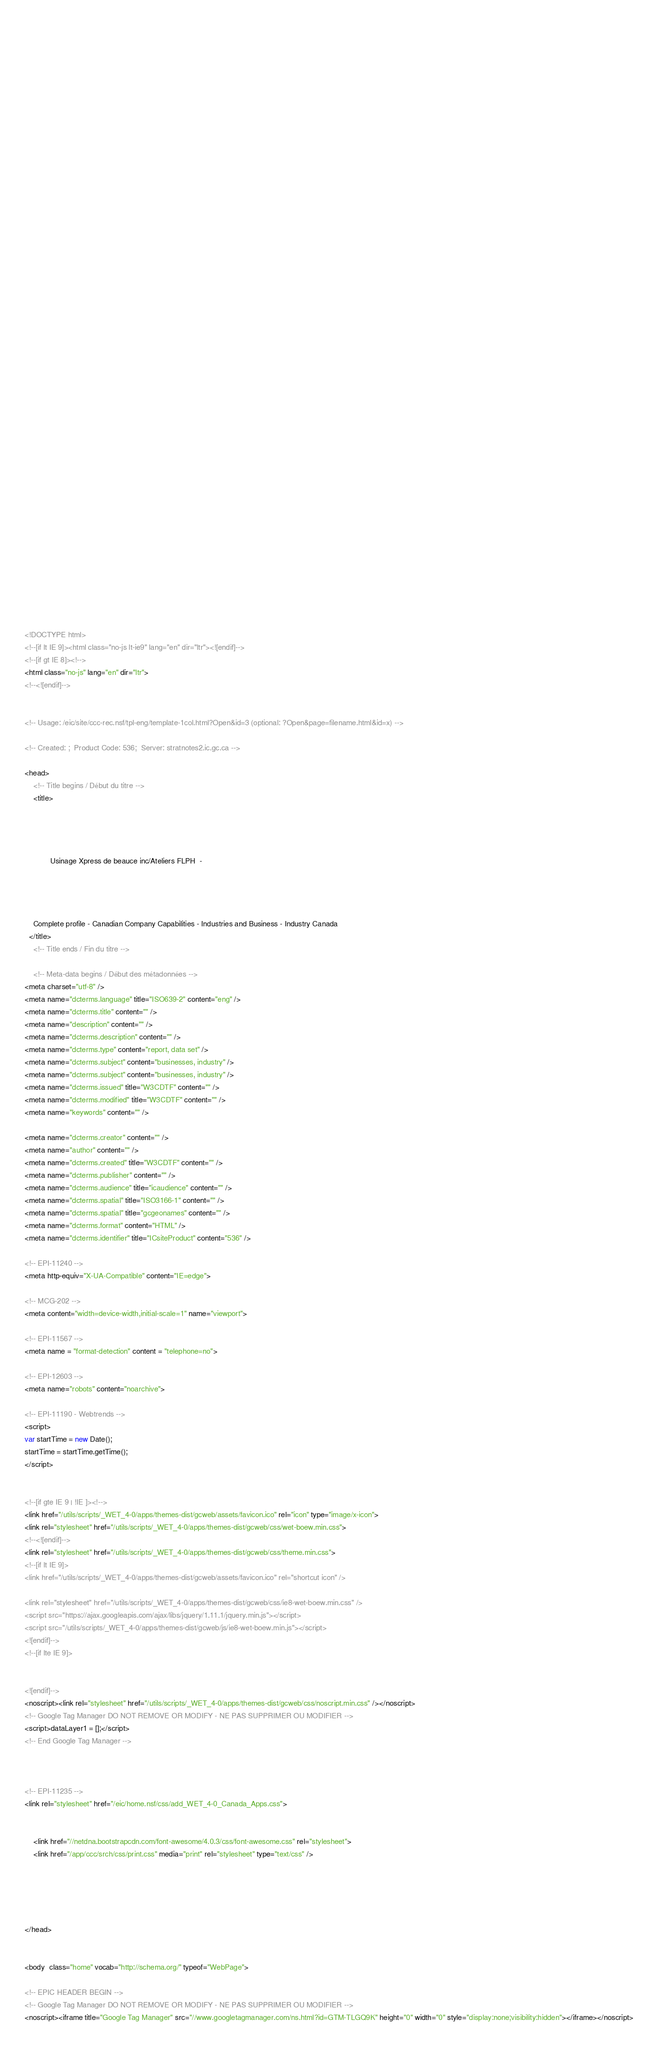<code> <loc_0><loc_0><loc_500><loc_500><_HTML_>


















	






  
  
  
  































	
	
	



<!DOCTYPE html>
<!--[if lt IE 9]><html class="no-js lt-ie9" lang="en" dir="ltr"><![endif]-->
<!--[if gt IE 8]><!-->
<html class="no-js" lang="en" dir="ltr">
<!--<![endif]-->


<!-- Usage: /eic/site/ccc-rec.nsf/tpl-eng/template-1col.html?Open&id=3 (optional: ?Open&page=filename.html&id=x) -->

<!-- Created: ;  Product Code: 536;  Server: stratnotes2.ic.gc.ca -->

<head>
	<!-- Title begins / Début du titre -->
	<title>
    
            
        
          
            Usinage Xpress de beauce inc/Ateliers FLPH  -
          
        
      
    
    Complete profile - Canadian Company Capabilities - Industries and Business - Industry Canada
  </title>
	<!-- Title ends / Fin du titre -->
 
	<!-- Meta-data begins / Début des métadonnées -->
<meta charset="utf-8" />
<meta name="dcterms.language" title="ISO639-2" content="eng" />
<meta name="dcterms.title" content="" />
<meta name="description" content="" />
<meta name="dcterms.description" content="" />
<meta name="dcterms.type" content="report, data set" />
<meta name="dcterms.subject" content="businesses, industry" />
<meta name="dcterms.subject" content="businesses, industry" />
<meta name="dcterms.issued" title="W3CDTF" content="" />
<meta name="dcterms.modified" title="W3CDTF" content="" />
<meta name="keywords" content="" />

<meta name="dcterms.creator" content="" />
<meta name="author" content="" />
<meta name="dcterms.created" title="W3CDTF" content="" />
<meta name="dcterms.publisher" content="" />
<meta name="dcterms.audience" title="icaudience" content="" />
<meta name="dcterms.spatial" title="ISO3166-1" content="" />
<meta name="dcterms.spatial" title="gcgeonames" content="" />
<meta name="dcterms.format" content="HTML" />
<meta name="dcterms.identifier" title="ICsiteProduct" content="536" />

<!-- EPI-11240 -->
<meta http-equiv="X-UA-Compatible" content="IE=edge">

<!-- MCG-202 -->
<meta content="width=device-width,initial-scale=1" name="viewport">

<!-- EPI-11567 -->
<meta name = "format-detection" content = "telephone=no">

<!-- EPI-12603 -->
<meta name="robots" content="noarchive">

<!-- EPI-11190 - Webtrends -->
<script>
var startTime = new Date();
startTime = startTime.getTime();
</script>


<!--[if gte IE 9 | !IE ]><!-->
<link href="/utils/scripts/_WET_4-0/apps/themes-dist/gcweb/assets/favicon.ico" rel="icon" type="image/x-icon">
<link rel="stylesheet" href="/utils/scripts/_WET_4-0/apps/themes-dist/gcweb/css/wet-boew.min.css">
<!--<![endif]-->
<link rel="stylesheet" href="/utils/scripts/_WET_4-0/apps/themes-dist/gcweb/css/theme.min.css">
<!--[if lt IE 9]>
<link href="/utils/scripts/_WET_4-0/apps/themes-dist/gcweb/assets/favicon.ico" rel="shortcut icon" />

<link rel="stylesheet" href="/utils/scripts/_WET_4-0/apps/themes-dist/gcweb/css/ie8-wet-boew.min.css" />
<script src="https://ajax.googleapis.com/ajax/libs/jquery/1.11.1/jquery.min.js"></script>
<script src="/utils/scripts/_WET_4-0/apps/themes-dist/gcweb/js/ie8-wet-boew.min.js"></script>
<![endif]-->
<!--[if lte IE 9]>


<![endif]-->
<noscript><link rel="stylesheet" href="/utils/scripts/_WET_4-0/apps/themes-dist/gcweb/css/noscript.min.css" /></noscript>
<!-- Google Tag Manager DO NOT REMOVE OR MODIFY - NE PAS SUPPRIMER OU MODIFIER -->
<script>dataLayer1 = [];</script>
<!-- End Google Tag Manager -->



<!-- EPI-11235 -->
<link rel="stylesheet" href="/eic/home.nsf/css/add_WET_4-0_Canada_Apps.css">


  	<link href="//netdna.bootstrapcdn.com/font-awesome/4.0.3/css/font-awesome.css" rel="stylesheet">
  	<link href="/app/ccc/srch/css/print.css" media="print" rel="stylesheet" type="text/css" />
   




</head>
 

<body  class="home" vocab="http://schema.org/" typeof="WebPage">
 
<!-- EPIC HEADER BEGIN -->
<!-- Google Tag Manager DO NOT REMOVE OR MODIFY - NE PAS SUPPRIMER OU MODIFIER -->
<noscript><iframe title="Google Tag Manager" src="//www.googletagmanager.com/ns.html?id=GTM-TLGQ9K" height="0" width="0" style="display:none;visibility:hidden"></iframe></noscript></code> 